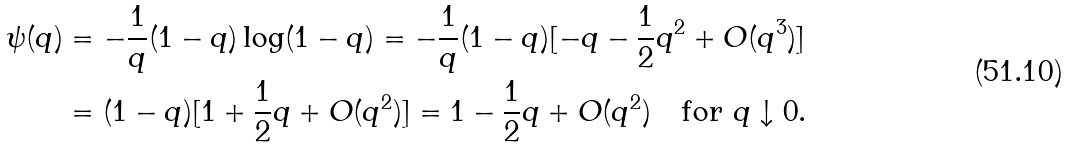<formula> <loc_0><loc_0><loc_500><loc_500>\psi ( q ) & = - \frac { 1 } { q } ( 1 - q ) \log ( 1 - q ) = - \frac { 1 } { q } ( 1 - q ) [ - q - \frac { 1 } { 2 } q ^ { 2 } + O ( q ^ { 3 } ) ] \\ & = ( 1 - q ) [ 1 + \frac { 1 } { 2 } q + O ( q ^ { 2 } ) ] = 1 - \frac { 1 } { 2 } q + O ( q ^ { 2 } ) \quad \text {for } q \downarrow 0 .</formula> 